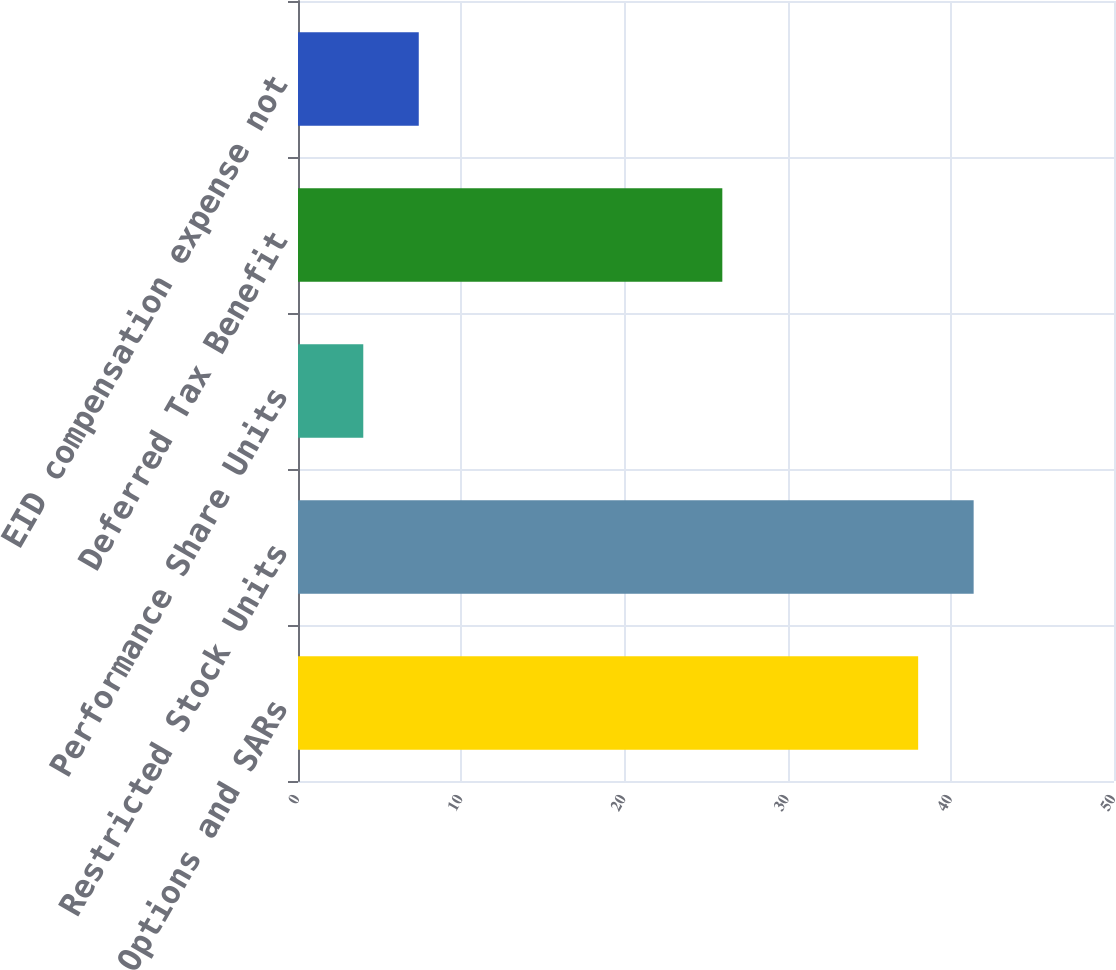Convert chart to OTSL. <chart><loc_0><loc_0><loc_500><loc_500><bar_chart><fcel>Options and SARs<fcel>Restricted Stock Units<fcel>Performance Share Units<fcel>Deferred Tax Benefit<fcel>EID compensation expense not<nl><fcel>38<fcel>41.4<fcel>4<fcel>26<fcel>7.4<nl></chart> 